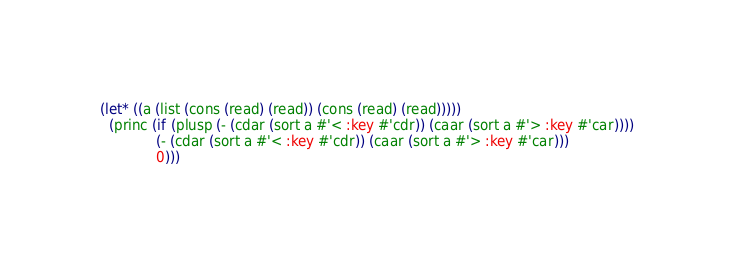Convert code to text. <code><loc_0><loc_0><loc_500><loc_500><_Lisp_>(let* ((a (list (cons (read) (read)) (cons (read) (read)))))
  (princ (if (plusp (- (cdar (sort a #'< :key #'cdr)) (caar (sort a #'> :key #'car))))
             (- (cdar (sort a #'< :key #'cdr)) (caar (sort a #'> :key #'car)))
             0)))</code> 